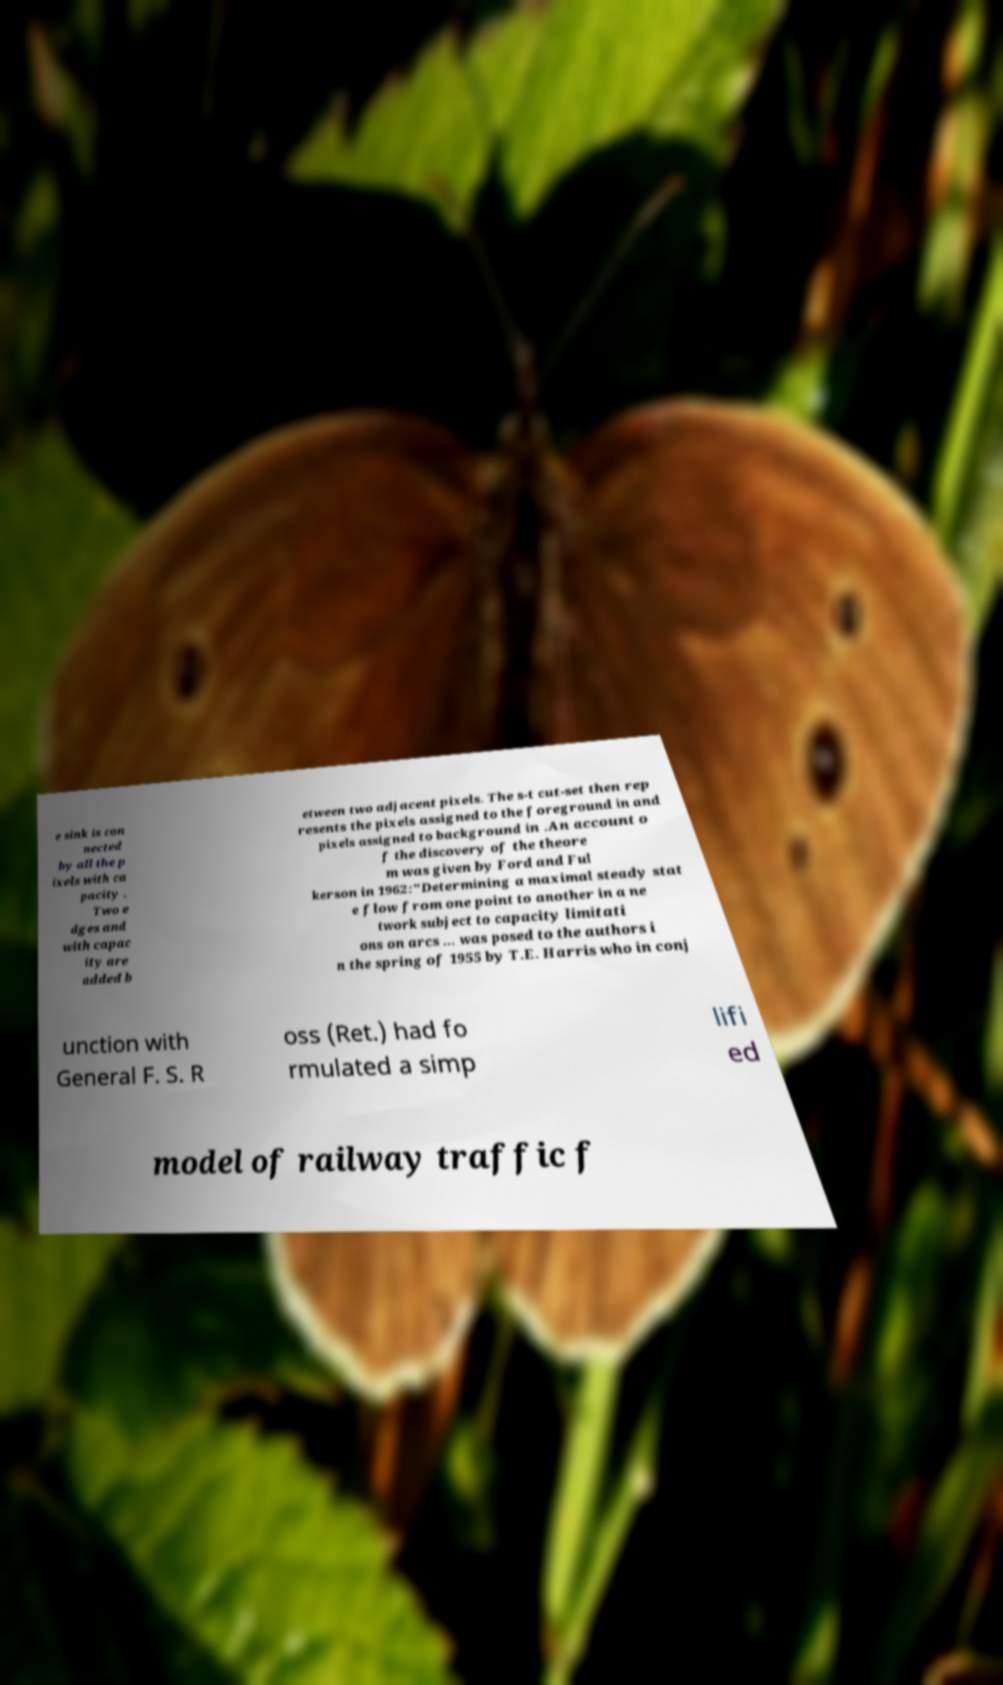Can you read and provide the text displayed in the image?This photo seems to have some interesting text. Can you extract and type it out for me? e sink is con nected by all the p ixels with ca pacity . Two e dges and with capac ity are added b etween two adjacent pixels. The s-t cut-set then rep resents the pixels assigned to the foreground in and pixels assigned to background in .An account o f the discovery of the theore m was given by Ford and Ful kerson in 1962:"Determining a maximal steady stat e flow from one point to another in a ne twork subject to capacity limitati ons on arcs ... was posed to the authors i n the spring of 1955 by T.E. Harris who in conj unction with General F. S. R oss (Ret.) had fo rmulated a simp lifi ed model of railway traffic f 